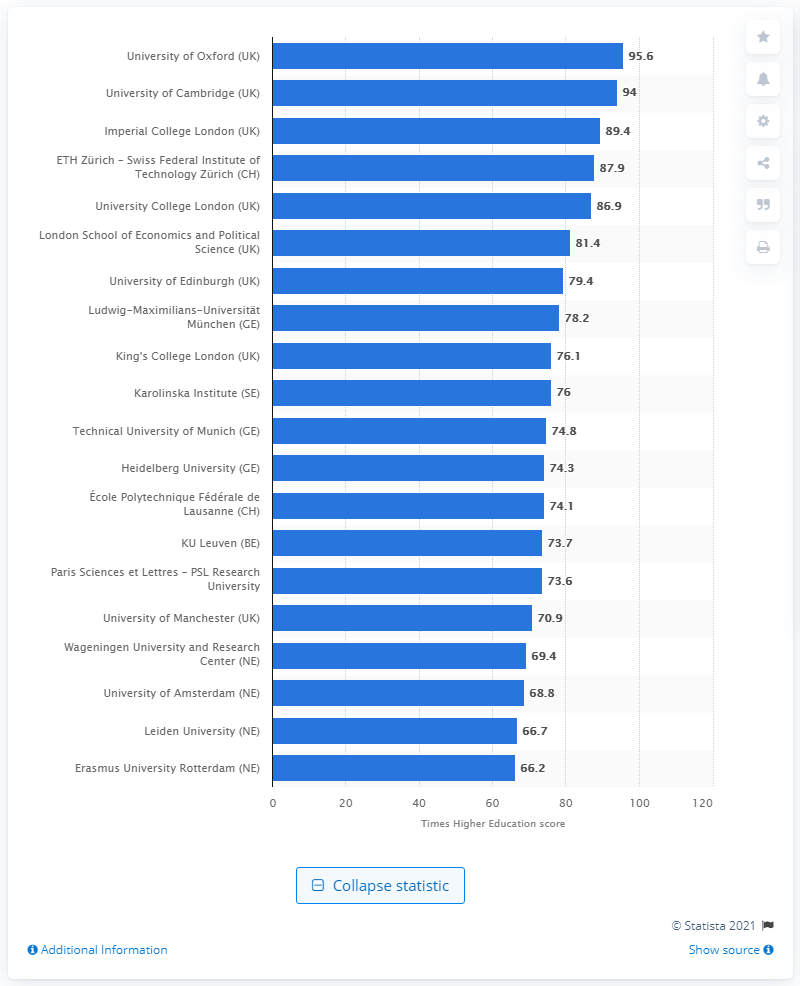Indicate a few pertinent items in this graphic. In the 2020/21 academic year, the University of Oxford achieved a score of 95.6. 